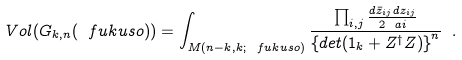<formula> <loc_0><loc_0><loc_500><loc_500>V o l ( G _ { k , n } ( \ f u k u s o ) ) = \int _ { M ( n - k , k ; \ f u k u s o ) } \frac { \prod _ { i , j } \frac { d { \bar { z } } _ { i j } d z _ { i j } } { 2 \ a i } } { \left \{ d e t ( { 1 } _ { k } + Z ^ { \dagger } Z ) \right \} ^ { n } } \ .</formula> 